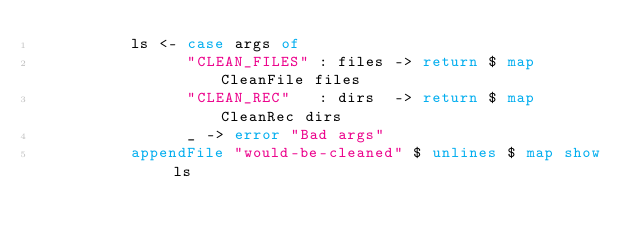<code> <loc_0><loc_0><loc_500><loc_500><_Haskell_>          ls <- case args of
                "CLEAN_FILES" : files -> return $ map CleanFile files
                "CLEAN_REC"   : dirs  -> return $ map CleanRec dirs
                _ -> error "Bad args"
          appendFile "would-be-cleaned" $ unlines $ map show ls
</code> 